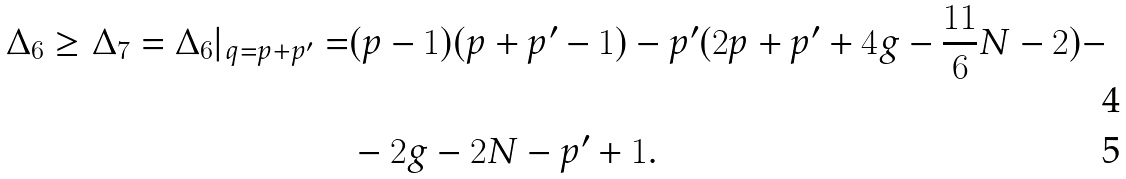Convert formula to latex. <formula><loc_0><loc_0><loc_500><loc_500>\Delta _ { 6 } \geq \Delta _ { 7 } = \Delta _ { 6 } | _ { q = p + p ^ { \prime } } = & ( p - 1 ) ( p + p ^ { \prime } - 1 ) - p ^ { \prime } ( 2 p + p ^ { \prime } + 4 g - \frac { 1 1 } { 6 } N - 2 ) - \\ & - 2 g - 2 N - p ^ { \prime } + 1 .</formula> 